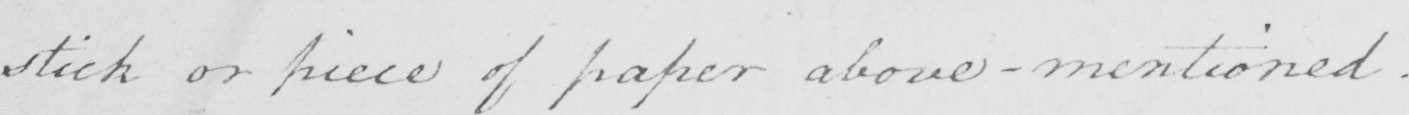What is written in this line of handwriting? stick or piece of paper above-mentioned  . 